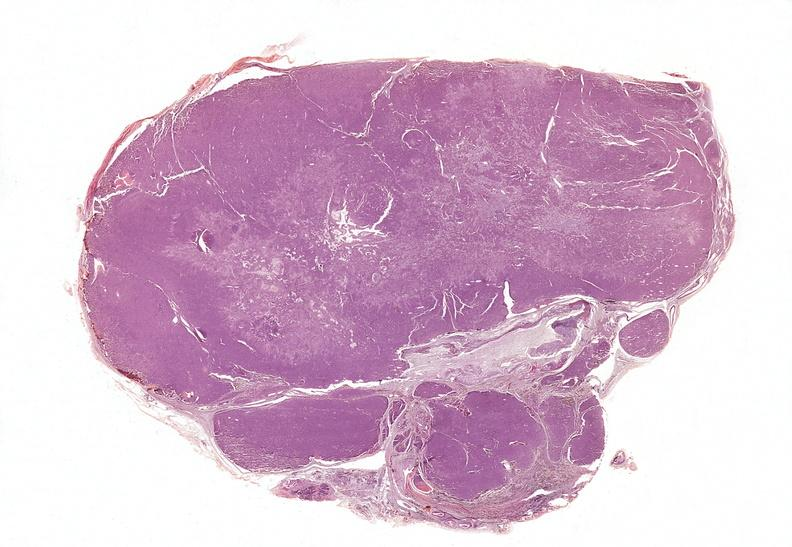does metastatic carcinoma show parathyroid, adenoma, functional?
Answer the question using a single word or phrase. No 